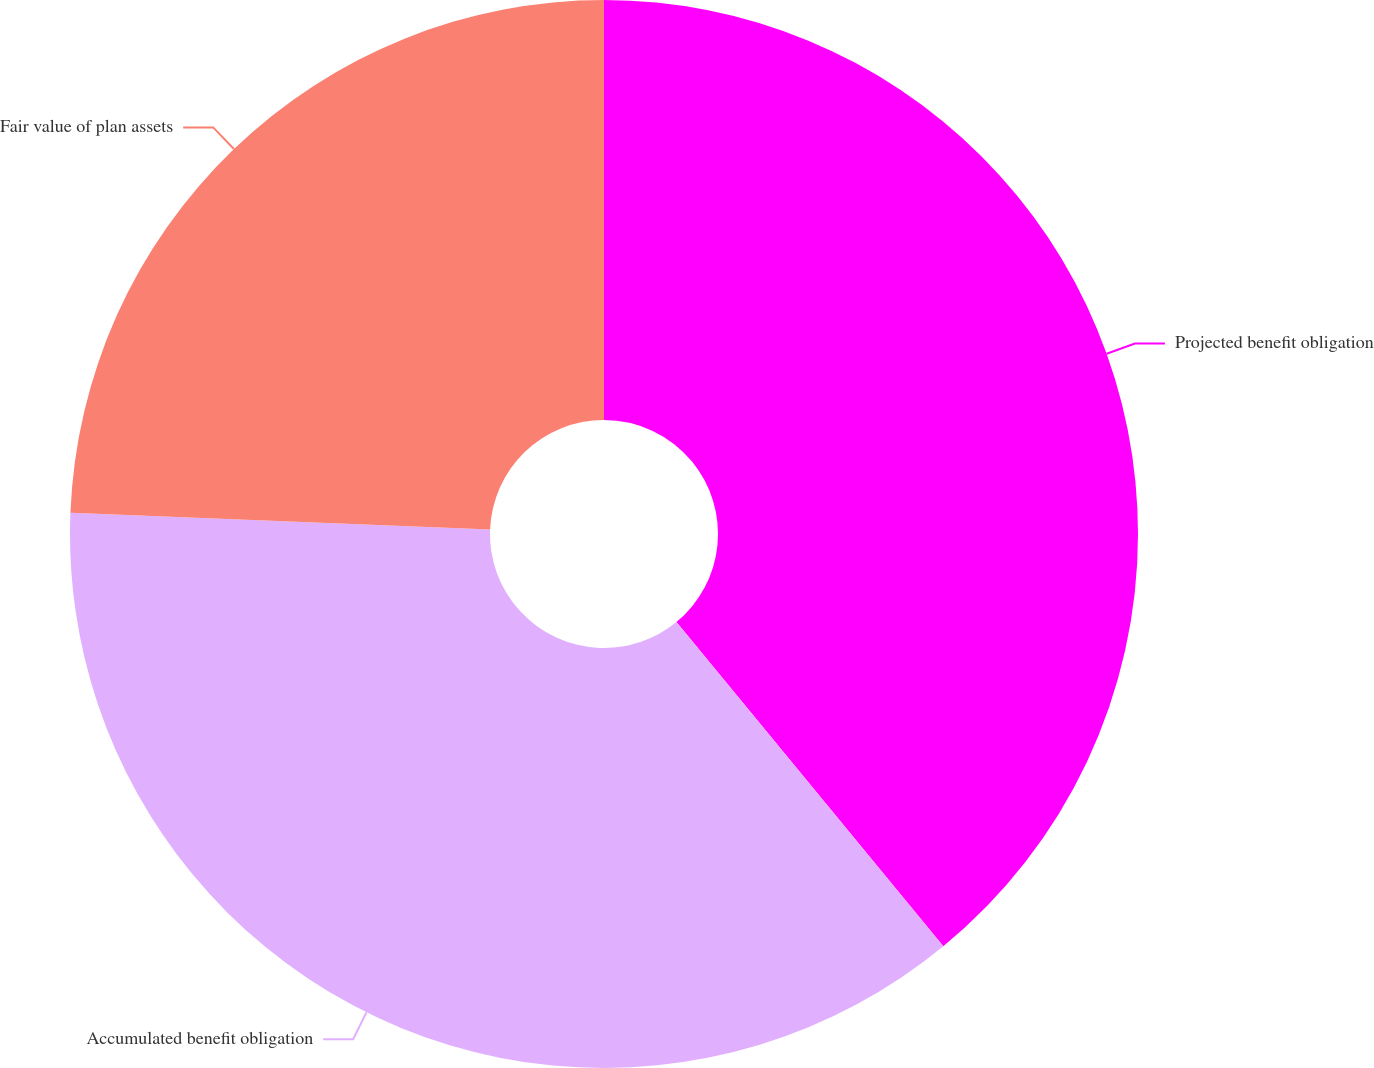Convert chart to OTSL. <chart><loc_0><loc_0><loc_500><loc_500><pie_chart><fcel>Projected benefit obligation<fcel>Accumulated benefit obligation<fcel>Fair value of plan assets<nl><fcel>39.04%<fcel>36.59%<fcel>24.37%<nl></chart> 